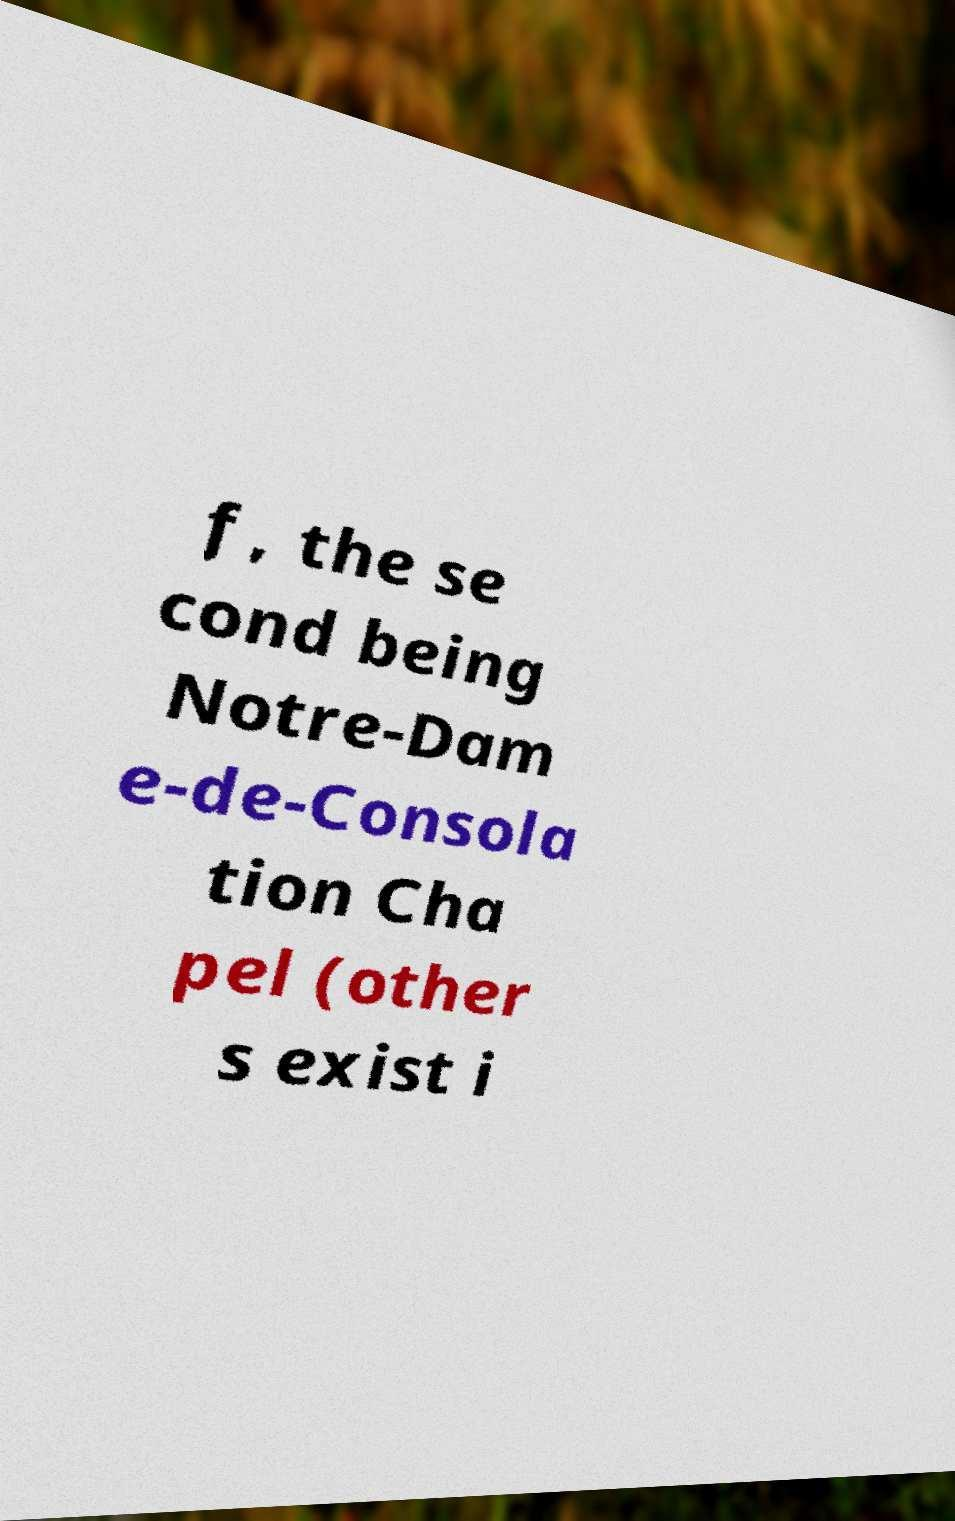Can you accurately transcribe the text from the provided image for me? f, the se cond being Notre-Dam e-de-Consola tion Cha pel (other s exist i 